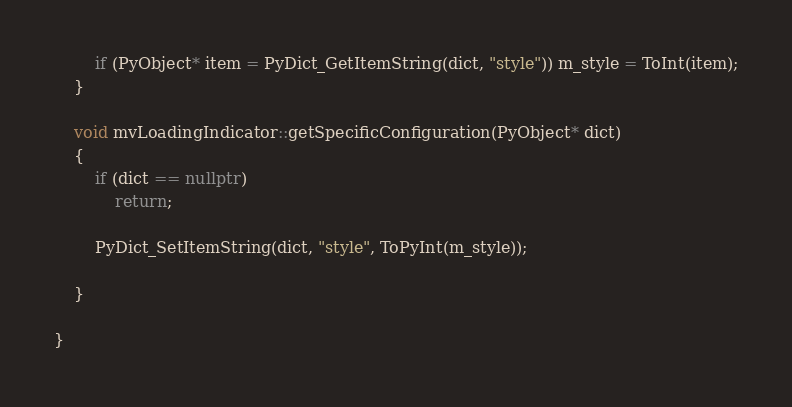<code> <loc_0><loc_0><loc_500><loc_500><_C++_>        if (PyObject* item = PyDict_GetItemString(dict, "style")) m_style = ToInt(item);
    }

    void mvLoadingIndicator::getSpecificConfiguration(PyObject* dict)
    {
        if (dict == nullptr)
            return;

        PyDict_SetItemString(dict, "style", ToPyInt(m_style));

    }

}</code> 